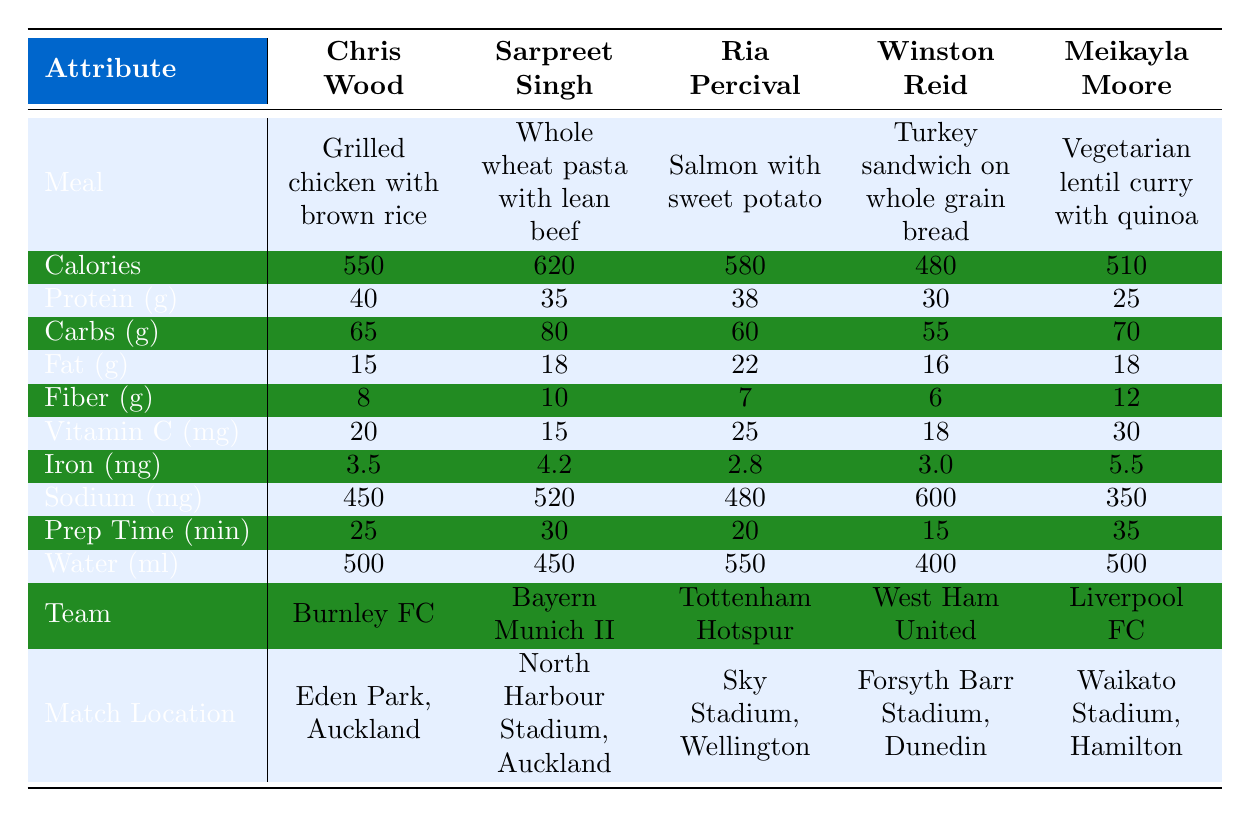What is the calorie content of Winston Reid's pre-match meal? According to the table, the calories for Winston Reid's meal (Turkey sandwich on whole grain bread) is listed as 480.
Answer: 480 Which meal has the highest protein content? By comparing the protein values in the table, Grilled chicken with brown rice (40 grams) has the highest protein content above the others: Whole wheat pasta with lean beef (35g), Salmon with sweet potato (38g), Turkey sandwich (30g), and Vegetarian lentil curry (25g).
Answer: Grilled chicken with brown rice What is the total carbohydrate content of Sarpreet Singh's and Ria Percival's meals combined? The carbohydrate content for Sarpreet Singh's meal is 80 grams, and for Ria Percival's it is 60 grams. Adding these gives 80 + 60 = 140 grams.
Answer: 140 Is Meikayla Moore's meal higher in fiber than Ria Percival's meal? The table shows Meikayla Moore's fiber content as 12 grams and Ria Percival's as 7 grams. Since 12 is greater than 7, Meikayla Moore's meal has more fiber.
Answer: Yes What is the average preparation time for all meals? The preparation times are 25, 30, 20, 15, and 35 minutes. Adding these gives a total of 125 minutes. Dividing by the number of meals (5) gives an average of 125 / 5 = 25 minutes.
Answer: 25 Which player has the meal with the lowest sodium content? If we look at the sodium values, Meikayla Moore's meal has 350 mg, which is the lowest when compared to the others: 450 mg for Chris Wood, 520 mg for Sarpreet Singh, 480 mg for Ria Percival, and 600 mg for Winston Reid.
Answer: Meikayla Moore What is the difference in calories between the highest and lowest-calorie meals? The highest-calorie meal is Whole wheat pasta with lean beef (620 calories) and the lowest is Turkey sandwich on whole grain bread (480 calories). The difference is 620 - 480 = 140 calories.
Answer: 140 Does any meal provide more than 25 grams of protein? Checking the protein values, Grilled chicken with brown rice (40g), Salmon with sweet potato (38g), and Whole wheat pasta with lean beef (35g) all exceed 25 grams of protein. Thus, the answer is yes.
Answer: Yes Which team's player has the meal with the highest amount of Vitamin C? Ria Percival's meal provides 25 mg of Vitamin C, which is the highest compared to the others: Chris Wood (20mg), Sarpreet Singh (15mg), Winston Reid (18mg), and Meikayla Moore (30mg). So, Meikayla Moore, who plays for Liverpool FC, has the highest Vitamin C.
Answer: Liverpool FC Calculate the total water content in milliliters for all meals. The water contents for the meals are 500ml, 450ml, 550ml, 400ml, and 500ml. Adding these gives 500 + 450 + 550 + 400 + 500 = 2400ml.
Answer: 2400 